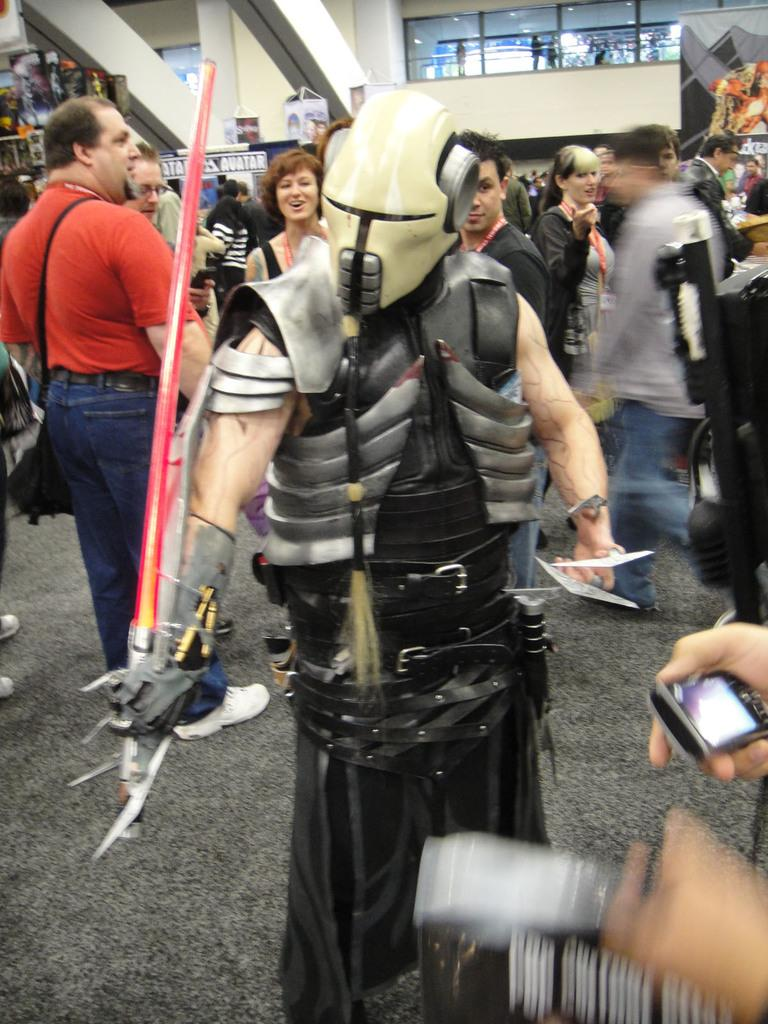What is the person in the image wearing? The person in the image is wearing a fancy dress. How many people are standing in the image? There is a group of people standing in the image. What can be seen illuminating the scene in the image? There are lights visible in the image. What decorations are present in the image? There are banners in the image. What type of flooring is visible in the image? There is a carpet in the image. What type of umbrella is being used as a prop in the image? There is no umbrella present in the image. What type of crime is being committed in the image? There is no crime being committed in the image; it is a scene with people standing and decorations. 